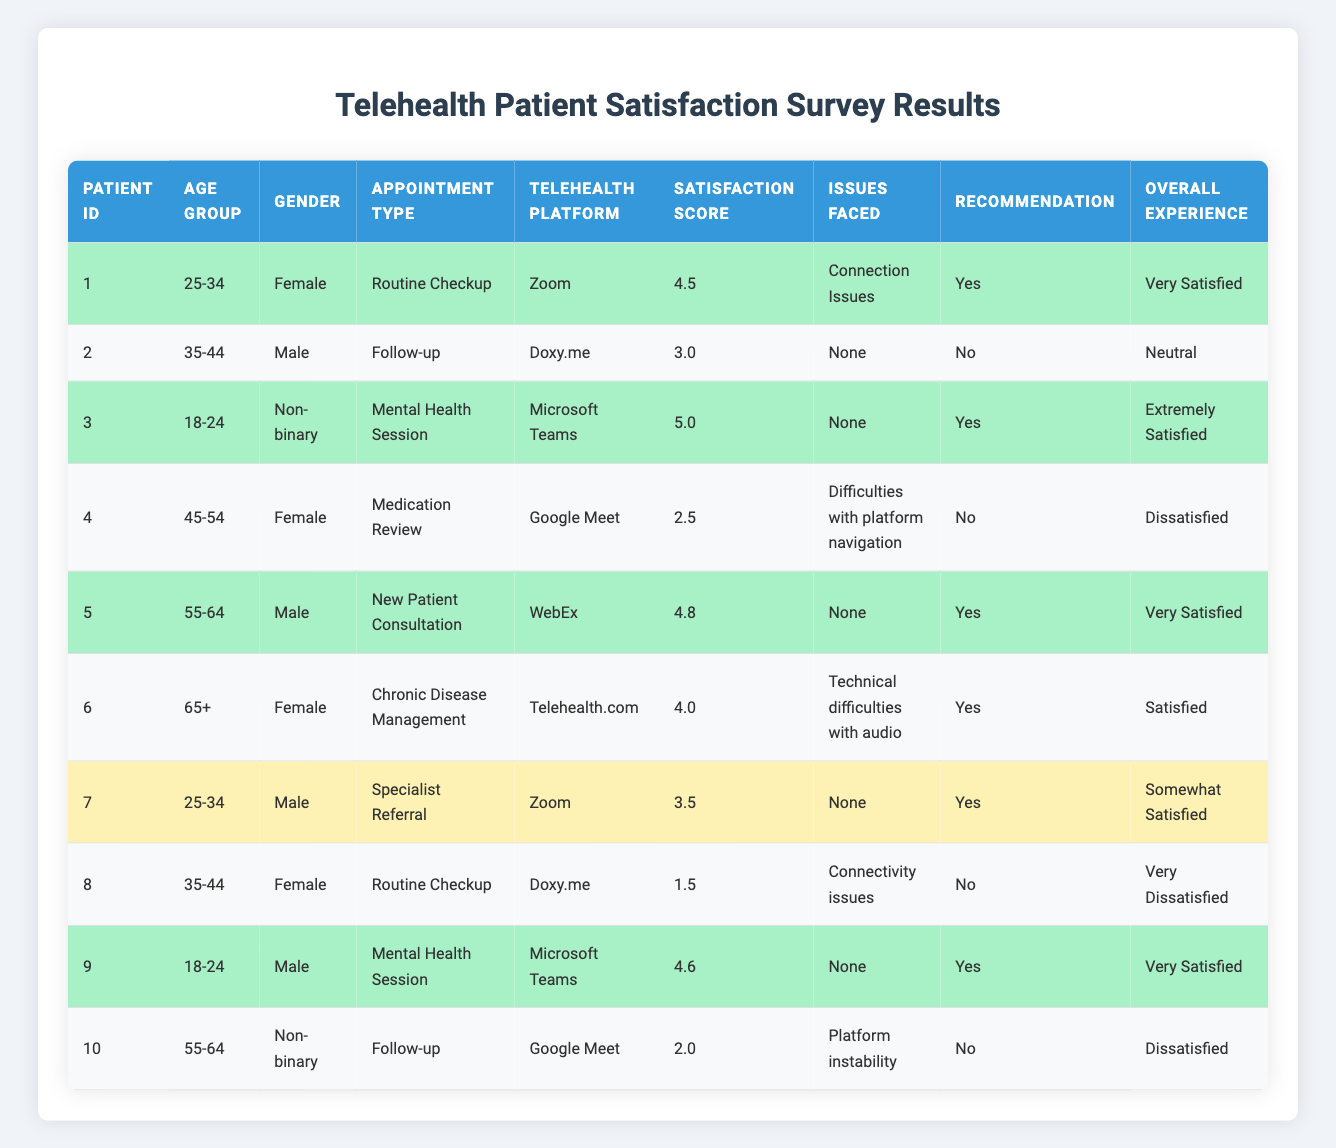What is the satisfaction score of patient ID 3? Patient ID 3 has a satisfaction score listed in the table as 5.0.
Answer: 5.0 How many patients reported issues during their telehealth appointments? By reviewing the "Issues Faced" column, we can count the number of non-empty entries. Out of 10 patients, 6 faced issues.
Answer: 6 What is the average satisfaction score for patients who recommended the service? First, identify the patients who recommended the service (Yes). These are patients 1, 3, 5, 6, 7, and 9, with scores of 4.5, 5.0, 4.8, 4.0, 3.5, and 4.6 respectively. The total score is 26.4, and there are 6 patients, so the average score = 26.4 / 6 = 4.4.
Answer: 4.4 Is there a patient aged 65 or older who was very satisfied with their telehealth experience? Looking at patients aged 65 and above, only patient ID 6 (aged 65+) has an overall experience classified as "Satisfied," not "Very Satisfied." Therefore, there is no.
Answer: No Which telehealth platform had the highest average satisfaction score? To find this, calculate the average score for each platform. The scores are: Zoom (4.0), Doxy.me (2.3), Microsoft Teams (4.3), Google Meet (2.25), WebEx (4.8), and Telehealth.com (4.0). The highest average score is from WebEx, which is 4.8.
Answer: WebEx What percentage of patients experienced connectivity or connection issues? Out of 10 patients, 3 faced specific connection issues. The percentage is (3/10) * 100 = 30%.
Answer: 30% How many male patients had an overall experience of "Dissatisfied"? By reviewing the table, we can identify the male patients: IDs 2, 5, and 10. Among these, only patient ID 10 has an overall experience of "Dissatisfied."
Answer: 1 Was the satisfaction score of any patients above 4.5 without any issues faced? Patient IDs 3 (5.0), 5 (4.8), and 9 (4.6) had scores above 4.5, and none reported issues faced. Thus, the answer is yes.
Answer: Yes What is the difference in satisfaction scores between the highest and lowest scores? The highest satisfaction score is 5.0 from patient ID 3, and the lowest is 1.5 from patient ID 8. Therefore, the difference is 5.0 - 1.5 = 3.5.
Answer: 3.5 